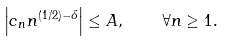<formula> <loc_0><loc_0><loc_500><loc_500>\left | c _ { n } n ^ { ( 1 / 2 ) - \delta } \right | \leq A , \quad \forall n \geq 1 .</formula> 